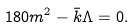<formula> <loc_0><loc_0><loc_500><loc_500>1 8 0 m ^ { 2 } - \bar { k } \Lambda = 0 .</formula> 